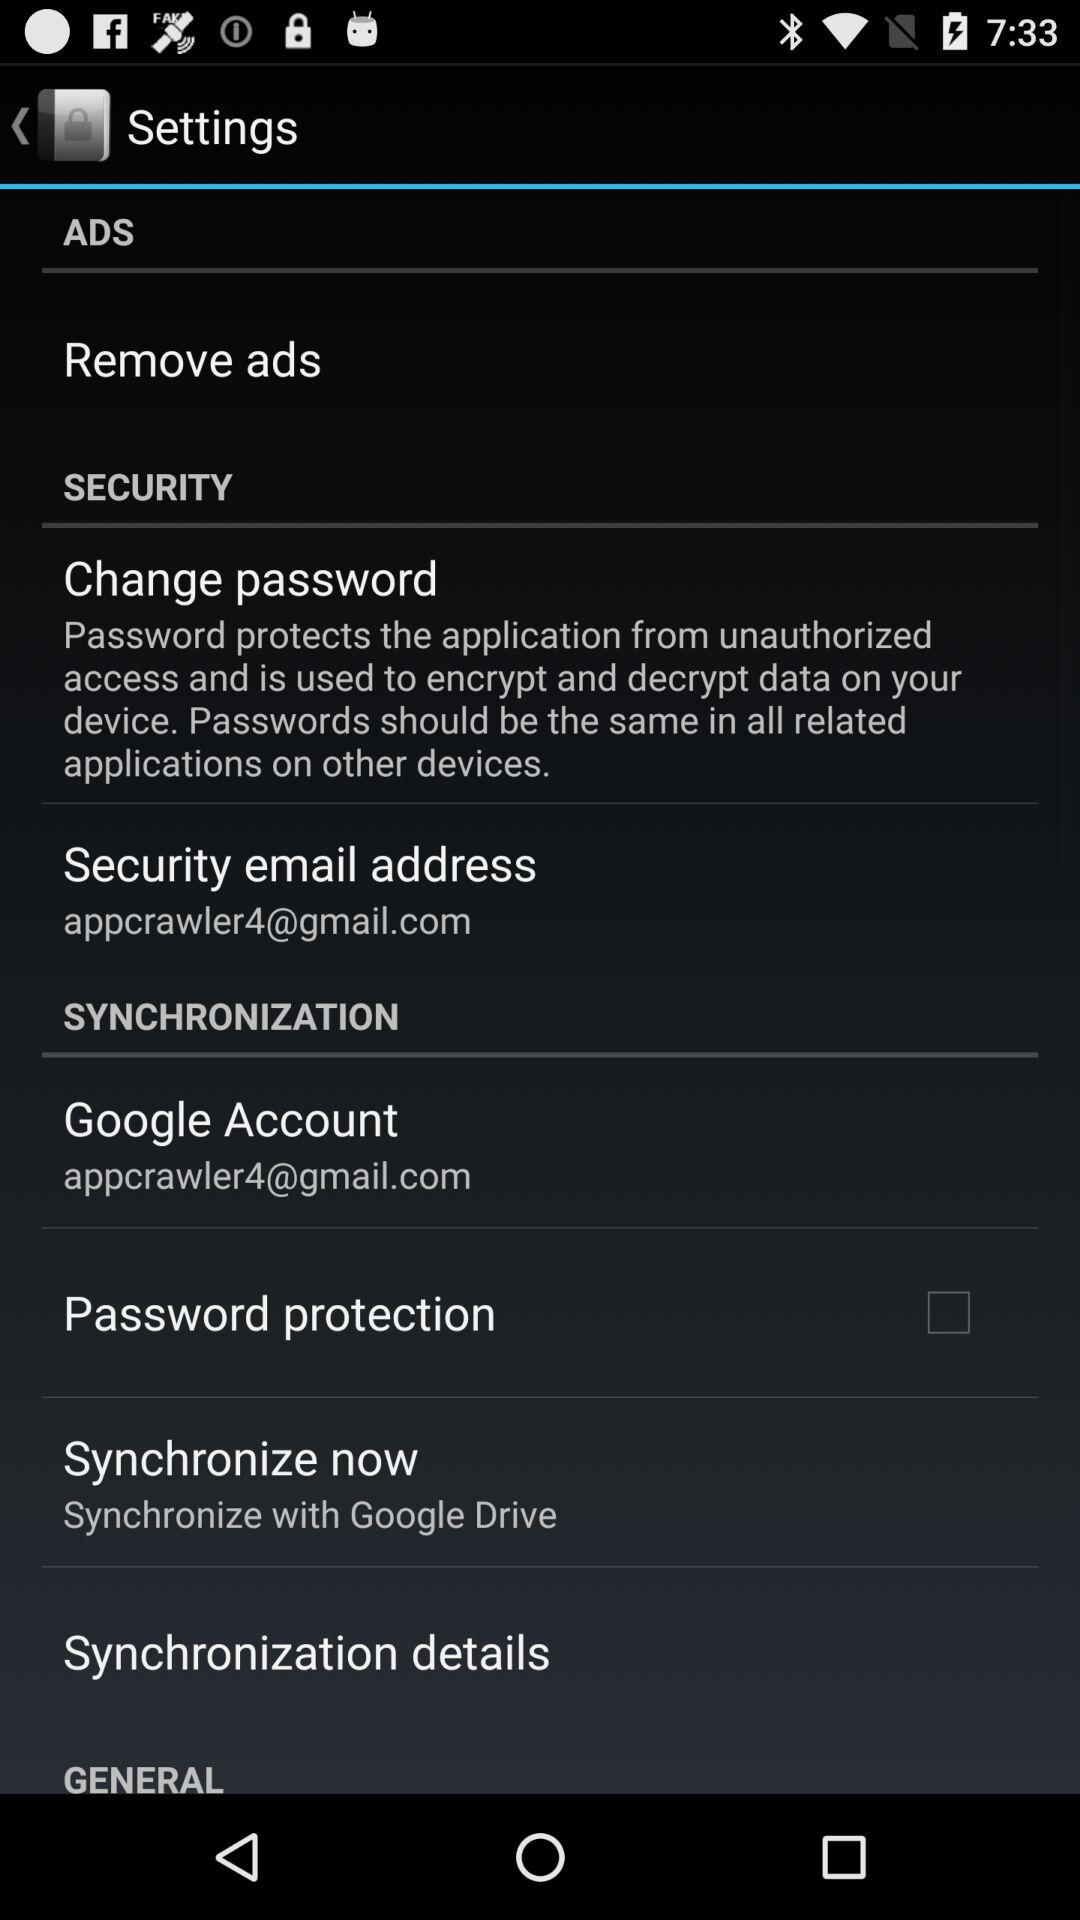What is the status of "Remove ads"?
When the provided information is insufficient, respond with <no answer>. <no answer> 